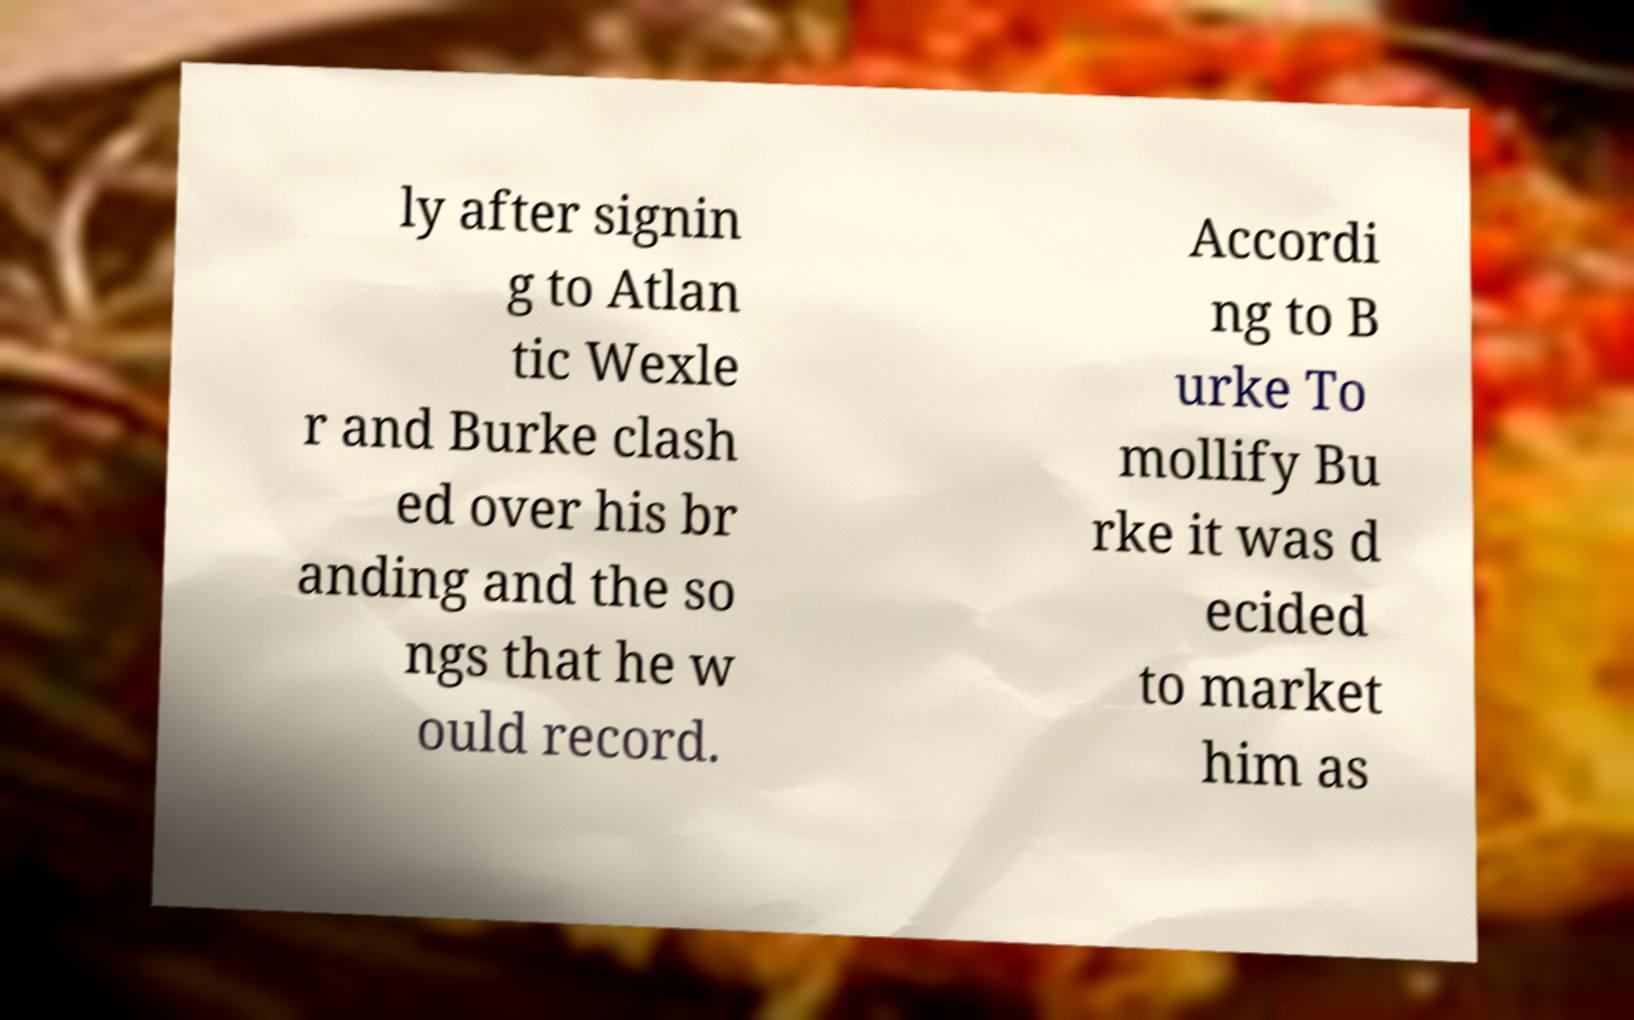For documentation purposes, I need the text within this image transcribed. Could you provide that? ly after signin g to Atlan tic Wexle r and Burke clash ed over his br anding and the so ngs that he w ould record. Accordi ng to B urke To mollify Bu rke it was d ecided to market him as 